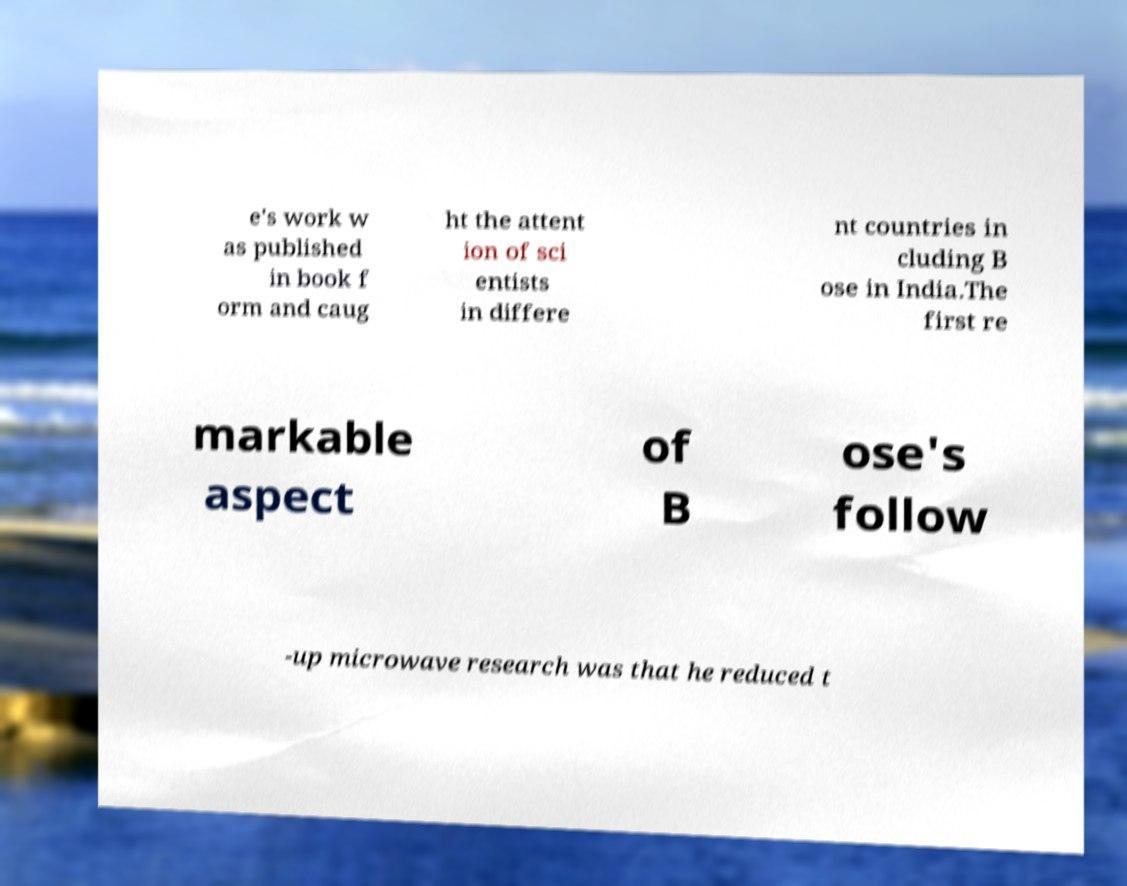What messages or text are displayed in this image? I need them in a readable, typed format. e's work w as published in book f orm and caug ht the attent ion of sci entists in differe nt countries in cluding B ose in India.The first re markable aspect of B ose's follow -up microwave research was that he reduced t 